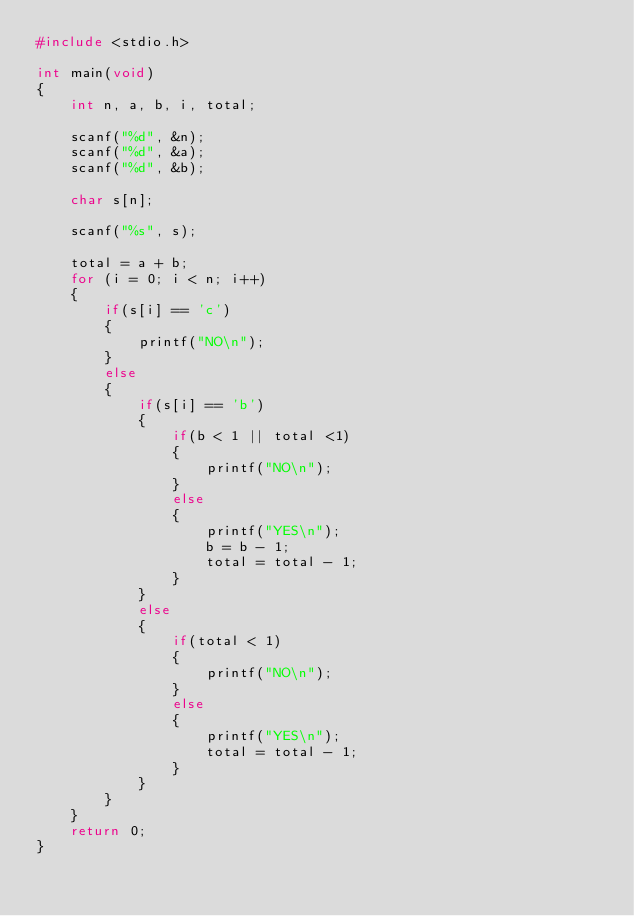<code> <loc_0><loc_0><loc_500><loc_500><_C_>#include <stdio.h>

int main(void)
{
	int n, a, b, i, total;
	
	scanf("%d", &n);
	scanf("%d", &a);
	scanf("%d", &b);
	
	char s[n];
	
	scanf("%s", s);
	
	total = a + b;
	for (i = 0; i < n; i++)
	{
		if(s[i] == 'c')
		{
			printf("NO\n");
		}
		else
		{
			if(s[i] == 'b')
			{
				if(b < 1 || total <1)
				{
					printf("NO\n");
				}
				else
				{
					printf("YES\n");
					b = b - 1;
					total = total - 1;
				}		
			}
			else
			{
				if(total < 1)
				{
					printf("NO\n");
				}
				else
				{
					printf("YES\n");
					total = total - 1;
				}
			}
		}
	}
	return 0;
}</code> 